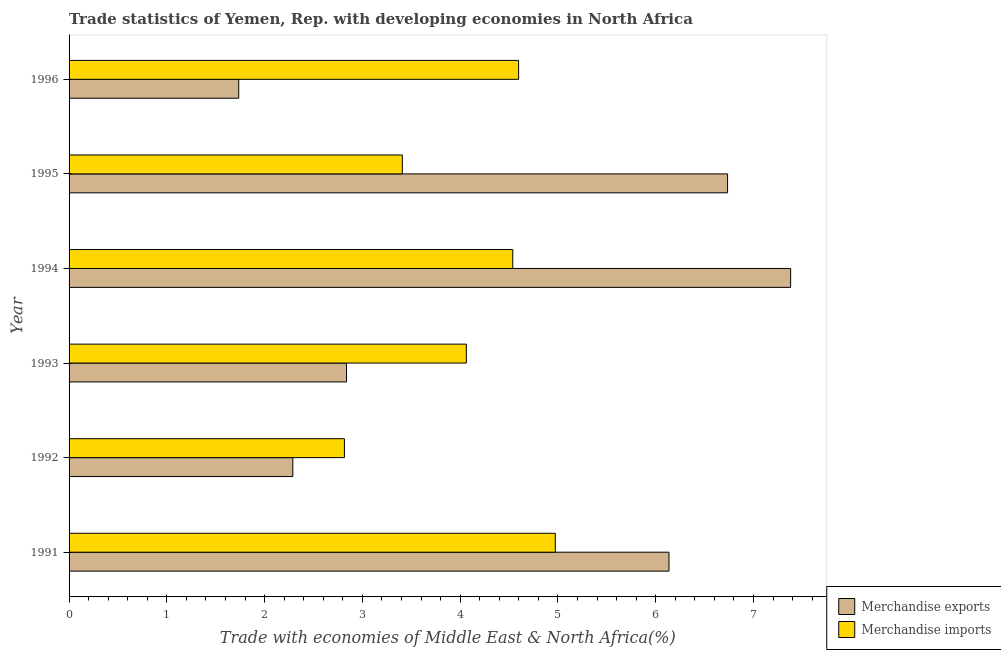How many bars are there on the 3rd tick from the top?
Your answer should be very brief. 2. In how many cases, is the number of bars for a given year not equal to the number of legend labels?
Provide a succinct answer. 0. What is the merchandise exports in 1991?
Ensure brevity in your answer.  6.14. Across all years, what is the maximum merchandise imports?
Offer a very short reply. 4.97. Across all years, what is the minimum merchandise imports?
Make the answer very short. 2.82. In which year was the merchandise imports maximum?
Provide a short and direct response. 1991. What is the total merchandise imports in the graph?
Your answer should be compact. 24.4. What is the difference between the merchandise exports in 1993 and that in 1996?
Keep it short and to the point. 1.1. What is the difference between the merchandise exports in 1993 and the merchandise imports in 1991?
Your response must be concise. -2.14. What is the average merchandise imports per year?
Your answer should be very brief. 4.07. In the year 1995, what is the difference between the merchandise exports and merchandise imports?
Keep it short and to the point. 3.33. Is the difference between the merchandise imports in 1991 and 1994 greater than the difference between the merchandise exports in 1991 and 1994?
Your answer should be very brief. Yes. What is the difference between the highest and the second highest merchandise exports?
Provide a short and direct response. 0.65. What is the difference between the highest and the lowest merchandise exports?
Provide a short and direct response. 5.64. What does the 1st bar from the top in 1996 represents?
Provide a succinct answer. Merchandise imports. What does the 2nd bar from the bottom in 1996 represents?
Provide a short and direct response. Merchandise imports. Are all the bars in the graph horizontal?
Ensure brevity in your answer.  Yes. Are the values on the major ticks of X-axis written in scientific E-notation?
Your answer should be very brief. No. How many legend labels are there?
Provide a succinct answer. 2. What is the title of the graph?
Ensure brevity in your answer.  Trade statistics of Yemen, Rep. with developing economies in North Africa. What is the label or title of the X-axis?
Your response must be concise. Trade with economies of Middle East & North Africa(%). What is the label or title of the Y-axis?
Your answer should be compact. Year. What is the Trade with economies of Middle East & North Africa(%) of Merchandise exports in 1991?
Make the answer very short. 6.14. What is the Trade with economies of Middle East & North Africa(%) of Merchandise imports in 1991?
Give a very brief answer. 4.97. What is the Trade with economies of Middle East & North Africa(%) of Merchandise exports in 1992?
Your response must be concise. 2.29. What is the Trade with economies of Middle East & North Africa(%) of Merchandise imports in 1992?
Your response must be concise. 2.82. What is the Trade with economies of Middle East & North Africa(%) of Merchandise exports in 1993?
Keep it short and to the point. 2.84. What is the Trade with economies of Middle East & North Africa(%) of Merchandise imports in 1993?
Your answer should be very brief. 4.06. What is the Trade with economies of Middle East & North Africa(%) in Merchandise exports in 1994?
Ensure brevity in your answer.  7.38. What is the Trade with economies of Middle East & North Africa(%) of Merchandise imports in 1994?
Make the answer very short. 4.54. What is the Trade with economies of Middle East & North Africa(%) of Merchandise exports in 1995?
Make the answer very short. 6.73. What is the Trade with economies of Middle East & North Africa(%) of Merchandise imports in 1995?
Offer a terse response. 3.41. What is the Trade with economies of Middle East & North Africa(%) of Merchandise exports in 1996?
Your answer should be compact. 1.74. What is the Trade with economies of Middle East & North Africa(%) in Merchandise imports in 1996?
Provide a short and direct response. 4.6. Across all years, what is the maximum Trade with economies of Middle East & North Africa(%) in Merchandise exports?
Offer a terse response. 7.38. Across all years, what is the maximum Trade with economies of Middle East & North Africa(%) of Merchandise imports?
Your response must be concise. 4.97. Across all years, what is the minimum Trade with economies of Middle East & North Africa(%) of Merchandise exports?
Give a very brief answer. 1.74. Across all years, what is the minimum Trade with economies of Middle East & North Africa(%) of Merchandise imports?
Provide a short and direct response. 2.82. What is the total Trade with economies of Middle East & North Africa(%) of Merchandise exports in the graph?
Give a very brief answer. 27.11. What is the total Trade with economies of Middle East & North Africa(%) in Merchandise imports in the graph?
Your answer should be compact. 24.4. What is the difference between the Trade with economies of Middle East & North Africa(%) in Merchandise exports in 1991 and that in 1992?
Make the answer very short. 3.85. What is the difference between the Trade with economies of Middle East & North Africa(%) in Merchandise imports in 1991 and that in 1992?
Offer a terse response. 2.16. What is the difference between the Trade with economies of Middle East & North Africa(%) of Merchandise exports in 1991 and that in 1993?
Offer a terse response. 3.3. What is the difference between the Trade with economies of Middle East & North Africa(%) in Merchandise imports in 1991 and that in 1993?
Make the answer very short. 0.91. What is the difference between the Trade with economies of Middle East & North Africa(%) of Merchandise exports in 1991 and that in 1994?
Your answer should be very brief. -1.24. What is the difference between the Trade with economies of Middle East & North Africa(%) of Merchandise imports in 1991 and that in 1994?
Keep it short and to the point. 0.43. What is the difference between the Trade with economies of Middle East & North Africa(%) in Merchandise exports in 1991 and that in 1995?
Offer a terse response. -0.6. What is the difference between the Trade with economies of Middle East & North Africa(%) of Merchandise imports in 1991 and that in 1995?
Keep it short and to the point. 1.56. What is the difference between the Trade with economies of Middle East & North Africa(%) in Merchandise exports in 1991 and that in 1996?
Offer a very short reply. 4.4. What is the difference between the Trade with economies of Middle East & North Africa(%) of Merchandise exports in 1992 and that in 1993?
Offer a very short reply. -0.55. What is the difference between the Trade with economies of Middle East & North Africa(%) of Merchandise imports in 1992 and that in 1993?
Your answer should be very brief. -1.25. What is the difference between the Trade with economies of Middle East & North Africa(%) of Merchandise exports in 1992 and that in 1994?
Your answer should be very brief. -5.09. What is the difference between the Trade with economies of Middle East & North Africa(%) in Merchandise imports in 1992 and that in 1994?
Ensure brevity in your answer.  -1.72. What is the difference between the Trade with economies of Middle East & North Africa(%) in Merchandise exports in 1992 and that in 1995?
Provide a short and direct response. -4.45. What is the difference between the Trade with economies of Middle East & North Africa(%) of Merchandise imports in 1992 and that in 1995?
Your response must be concise. -0.59. What is the difference between the Trade with economies of Middle East & North Africa(%) in Merchandise exports in 1992 and that in 1996?
Your response must be concise. 0.55. What is the difference between the Trade with economies of Middle East & North Africa(%) in Merchandise imports in 1992 and that in 1996?
Offer a terse response. -1.78. What is the difference between the Trade with economies of Middle East & North Africa(%) in Merchandise exports in 1993 and that in 1994?
Give a very brief answer. -4.54. What is the difference between the Trade with economies of Middle East & North Africa(%) in Merchandise imports in 1993 and that in 1994?
Give a very brief answer. -0.47. What is the difference between the Trade with economies of Middle East & North Africa(%) in Merchandise exports in 1993 and that in 1995?
Keep it short and to the point. -3.9. What is the difference between the Trade with economies of Middle East & North Africa(%) of Merchandise imports in 1993 and that in 1995?
Make the answer very short. 0.65. What is the difference between the Trade with economies of Middle East & North Africa(%) in Merchandise exports in 1993 and that in 1996?
Make the answer very short. 1.1. What is the difference between the Trade with economies of Middle East & North Africa(%) in Merchandise imports in 1993 and that in 1996?
Provide a short and direct response. -0.53. What is the difference between the Trade with economies of Middle East & North Africa(%) in Merchandise exports in 1994 and that in 1995?
Offer a terse response. 0.65. What is the difference between the Trade with economies of Middle East & North Africa(%) of Merchandise imports in 1994 and that in 1995?
Your response must be concise. 1.13. What is the difference between the Trade with economies of Middle East & North Africa(%) of Merchandise exports in 1994 and that in 1996?
Provide a short and direct response. 5.64. What is the difference between the Trade with economies of Middle East & North Africa(%) of Merchandise imports in 1994 and that in 1996?
Keep it short and to the point. -0.06. What is the difference between the Trade with economies of Middle East & North Africa(%) in Merchandise exports in 1995 and that in 1996?
Offer a very short reply. 5. What is the difference between the Trade with economies of Middle East & North Africa(%) in Merchandise imports in 1995 and that in 1996?
Provide a succinct answer. -1.19. What is the difference between the Trade with economies of Middle East & North Africa(%) of Merchandise exports in 1991 and the Trade with economies of Middle East & North Africa(%) of Merchandise imports in 1992?
Your response must be concise. 3.32. What is the difference between the Trade with economies of Middle East & North Africa(%) in Merchandise exports in 1991 and the Trade with economies of Middle East & North Africa(%) in Merchandise imports in 1993?
Provide a succinct answer. 2.07. What is the difference between the Trade with economies of Middle East & North Africa(%) in Merchandise exports in 1991 and the Trade with economies of Middle East & North Africa(%) in Merchandise imports in 1994?
Ensure brevity in your answer.  1.6. What is the difference between the Trade with economies of Middle East & North Africa(%) of Merchandise exports in 1991 and the Trade with economies of Middle East & North Africa(%) of Merchandise imports in 1995?
Your answer should be very brief. 2.73. What is the difference between the Trade with economies of Middle East & North Africa(%) in Merchandise exports in 1991 and the Trade with economies of Middle East & North Africa(%) in Merchandise imports in 1996?
Give a very brief answer. 1.54. What is the difference between the Trade with economies of Middle East & North Africa(%) of Merchandise exports in 1992 and the Trade with economies of Middle East & North Africa(%) of Merchandise imports in 1993?
Your answer should be very brief. -1.77. What is the difference between the Trade with economies of Middle East & North Africa(%) in Merchandise exports in 1992 and the Trade with economies of Middle East & North Africa(%) in Merchandise imports in 1994?
Ensure brevity in your answer.  -2.25. What is the difference between the Trade with economies of Middle East & North Africa(%) of Merchandise exports in 1992 and the Trade with economies of Middle East & North Africa(%) of Merchandise imports in 1995?
Ensure brevity in your answer.  -1.12. What is the difference between the Trade with economies of Middle East & North Africa(%) in Merchandise exports in 1992 and the Trade with economies of Middle East & North Africa(%) in Merchandise imports in 1996?
Offer a very short reply. -2.31. What is the difference between the Trade with economies of Middle East & North Africa(%) of Merchandise exports in 1993 and the Trade with economies of Middle East & North Africa(%) of Merchandise imports in 1994?
Provide a succinct answer. -1.7. What is the difference between the Trade with economies of Middle East & North Africa(%) in Merchandise exports in 1993 and the Trade with economies of Middle East & North Africa(%) in Merchandise imports in 1995?
Offer a terse response. -0.57. What is the difference between the Trade with economies of Middle East & North Africa(%) of Merchandise exports in 1993 and the Trade with economies of Middle East & North Africa(%) of Merchandise imports in 1996?
Make the answer very short. -1.76. What is the difference between the Trade with economies of Middle East & North Africa(%) in Merchandise exports in 1994 and the Trade with economies of Middle East & North Africa(%) in Merchandise imports in 1995?
Provide a succinct answer. 3.97. What is the difference between the Trade with economies of Middle East & North Africa(%) of Merchandise exports in 1994 and the Trade with economies of Middle East & North Africa(%) of Merchandise imports in 1996?
Provide a succinct answer. 2.78. What is the difference between the Trade with economies of Middle East & North Africa(%) in Merchandise exports in 1995 and the Trade with economies of Middle East & North Africa(%) in Merchandise imports in 1996?
Your answer should be very brief. 2.14. What is the average Trade with economies of Middle East & North Africa(%) in Merchandise exports per year?
Your answer should be very brief. 4.52. What is the average Trade with economies of Middle East & North Africa(%) of Merchandise imports per year?
Offer a very short reply. 4.07. In the year 1991, what is the difference between the Trade with economies of Middle East & North Africa(%) of Merchandise exports and Trade with economies of Middle East & North Africa(%) of Merchandise imports?
Provide a short and direct response. 1.16. In the year 1992, what is the difference between the Trade with economies of Middle East & North Africa(%) of Merchandise exports and Trade with economies of Middle East & North Africa(%) of Merchandise imports?
Provide a short and direct response. -0.53. In the year 1993, what is the difference between the Trade with economies of Middle East & North Africa(%) in Merchandise exports and Trade with economies of Middle East & North Africa(%) in Merchandise imports?
Keep it short and to the point. -1.23. In the year 1994, what is the difference between the Trade with economies of Middle East & North Africa(%) in Merchandise exports and Trade with economies of Middle East & North Africa(%) in Merchandise imports?
Keep it short and to the point. 2.84. In the year 1995, what is the difference between the Trade with economies of Middle East & North Africa(%) of Merchandise exports and Trade with economies of Middle East & North Africa(%) of Merchandise imports?
Provide a succinct answer. 3.33. In the year 1996, what is the difference between the Trade with economies of Middle East & North Africa(%) of Merchandise exports and Trade with economies of Middle East & North Africa(%) of Merchandise imports?
Your answer should be very brief. -2.86. What is the ratio of the Trade with economies of Middle East & North Africa(%) of Merchandise exports in 1991 to that in 1992?
Your answer should be compact. 2.68. What is the ratio of the Trade with economies of Middle East & North Africa(%) in Merchandise imports in 1991 to that in 1992?
Your response must be concise. 1.77. What is the ratio of the Trade with economies of Middle East & North Africa(%) in Merchandise exports in 1991 to that in 1993?
Provide a short and direct response. 2.16. What is the ratio of the Trade with economies of Middle East & North Africa(%) in Merchandise imports in 1991 to that in 1993?
Your answer should be compact. 1.22. What is the ratio of the Trade with economies of Middle East & North Africa(%) in Merchandise exports in 1991 to that in 1994?
Make the answer very short. 0.83. What is the ratio of the Trade with economies of Middle East & North Africa(%) in Merchandise imports in 1991 to that in 1994?
Ensure brevity in your answer.  1.1. What is the ratio of the Trade with economies of Middle East & North Africa(%) in Merchandise exports in 1991 to that in 1995?
Give a very brief answer. 0.91. What is the ratio of the Trade with economies of Middle East & North Africa(%) in Merchandise imports in 1991 to that in 1995?
Offer a very short reply. 1.46. What is the ratio of the Trade with economies of Middle East & North Africa(%) of Merchandise exports in 1991 to that in 1996?
Give a very brief answer. 3.54. What is the ratio of the Trade with economies of Middle East & North Africa(%) of Merchandise imports in 1991 to that in 1996?
Offer a terse response. 1.08. What is the ratio of the Trade with economies of Middle East & North Africa(%) of Merchandise exports in 1992 to that in 1993?
Your response must be concise. 0.81. What is the ratio of the Trade with economies of Middle East & North Africa(%) of Merchandise imports in 1992 to that in 1993?
Provide a short and direct response. 0.69. What is the ratio of the Trade with economies of Middle East & North Africa(%) in Merchandise exports in 1992 to that in 1994?
Offer a terse response. 0.31. What is the ratio of the Trade with economies of Middle East & North Africa(%) in Merchandise imports in 1992 to that in 1994?
Provide a succinct answer. 0.62. What is the ratio of the Trade with economies of Middle East & North Africa(%) in Merchandise exports in 1992 to that in 1995?
Your answer should be very brief. 0.34. What is the ratio of the Trade with economies of Middle East & North Africa(%) of Merchandise imports in 1992 to that in 1995?
Your response must be concise. 0.83. What is the ratio of the Trade with economies of Middle East & North Africa(%) of Merchandise exports in 1992 to that in 1996?
Keep it short and to the point. 1.32. What is the ratio of the Trade with economies of Middle East & North Africa(%) of Merchandise imports in 1992 to that in 1996?
Offer a terse response. 0.61. What is the ratio of the Trade with economies of Middle East & North Africa(%) in Merchandise exports in 1993 to that in 1994?
Offer a very short reply. 0.38. What is the ratio of the Trade with economies of Middle East & North Africa(%) of Merchandise imports in 1993 to that in 1994?
Offer a very short reply. 0.9. What is the ratio of the Trade with economies of Middle East & North Africa(%) in Merchandise exports in 1993 to that in 1995?
Your response must be concise. 0.42. What is the ratio of the Trade with economies of Middle East & North Africa(%) in Merchandise imports in 1993 to that in 1995?
Your answer should be very brief. 1.19. What is the ratio of the Trade with economies of Middle East & North Africa(%) of Merchandise exports in 1993 to that in 1996?
Keep it short and to the point. 1.64. What is the ratio of the Trade with economies of Middle East & North Africa(%) in Merchandise imports in 1993 to that in 1996?
Provide a succinct answer. 0.88. What is the ratio of the Trade with economies of Middle East & North Africa(%) of Merchandise exports in 1994 to that in 1995?
Your answer should be very brief. 1.1. What is the ratio of the Trade with economies of Middle East & North Africa(%) of Merchandise imports in 1994 to that in 1995?
Provide a short and direct response. 1.33. What is the ratio of the Trade with economies of Middle East & North Africa(%) in Merchandise exports in 1994 to that in 1996?
Ensure brevity in your answer.  4.25. What is the ratio of the Trade with economies of Middle East & North Africa(%) of Merchandise imports in 1994 to that in 1996?
Give a very brief answer. 0.99. What is the ratio of the Trade with economies of Middle East & North Africa(%) in Merchandise exports in 1995 to that in 1996?
Offer a very short reply. 3.88. What is the ratio of the Trade with economies of Middle East & North Africa(%) in Merchandise imports in 1995 to that in 1996?
Keep it short and to the point. 0.74. What is the difference between the highest and the second highest Trade with economies of Middle East & North Africa(%) in Merchandise exports?
Offer a very short reply. 0.65. What is the difference between the highest and the lowest Trade with economies of Middle East & North Africa(%) in Merchandise exports?
Give a very brief answer. 5.64. What is the difference between the highest and the lowest Trade with economies of Middle East & North Africa(%) in Merchandise imports?
Ensure brevity in your answer.  2.16. 